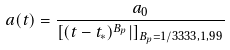Convert formula to latex. <formula><loc_0><loc_0><loc_500><loc_500>a ( t ) = \frac { a _ { 0 } } { [ ( t - t _ { * } ) ^ { B _ { p } } | ] _ { B _ { p } = 1 / 3 3 3 3 , 1 , 9 9 } }</formula> 